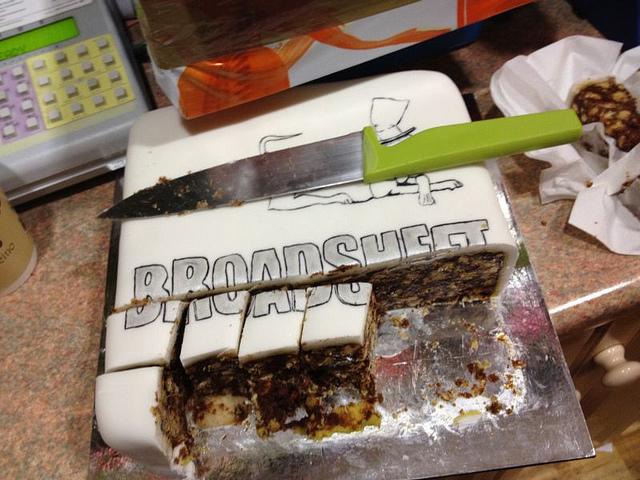How many pieces of cake are already cut?
Write a very short answer. 5. What color was the letters on the cake?
Short answer required. Silver. What did the cake have written on it?
Write a very short answer. Broadsheet. What type of food is this?
Quick response, please. Cake. 